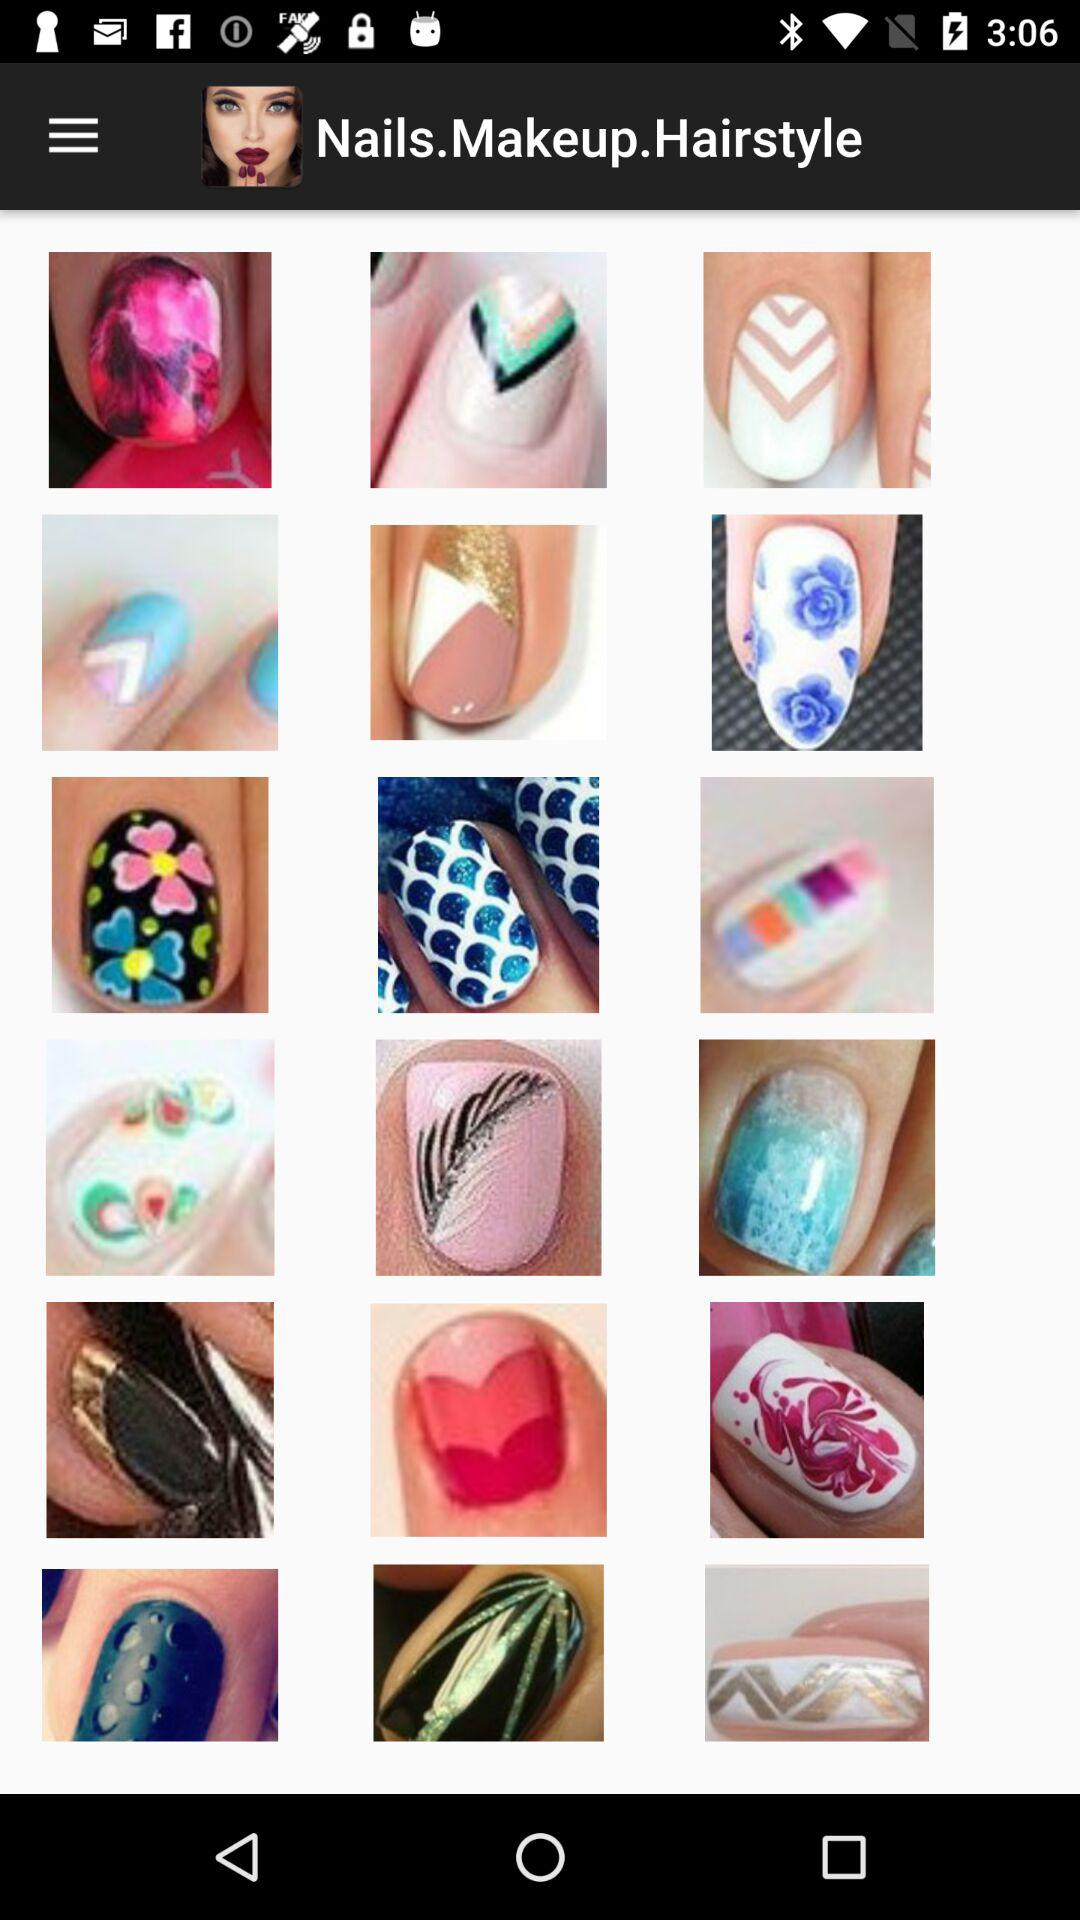How many nail art designs feature a rainbow?
Answer the question using a single word or phrase. 3 